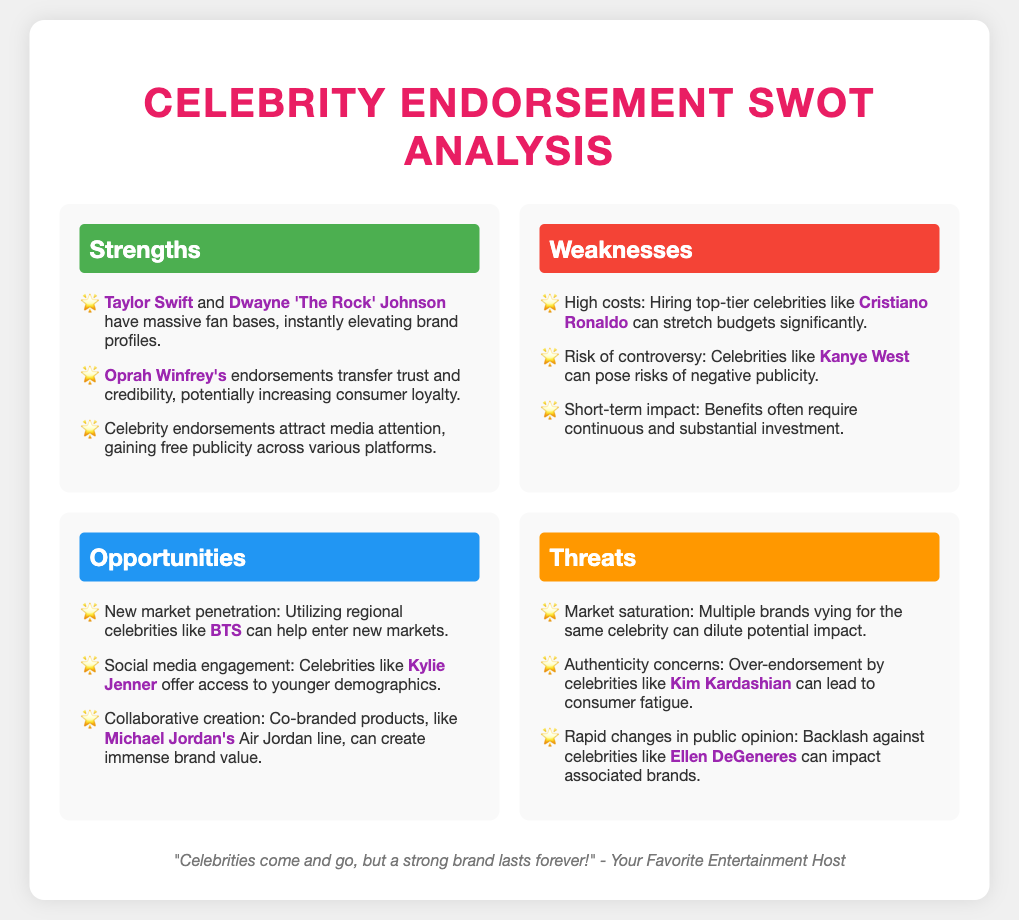What are the strengths listed in the document? The strengths section includes points about celebrities with massive fan bases that enhance brand profiles, endorsements that transfer trust, and media attention attracting free publicity.
Answer: Massive fan bases, trust and credibility, media attention Which celebrity is mentioned as a risk of controversy? The weaknesses section highlights the potential risk of negative publicity associated with certain celebrities.
Answer: Kanye West What type of opportunities does the document highlight for entering new markets? The opportunities section suggests utilizing regional celebrities for market penetration as a strategy.
Answer: Regional celebrities How many celebrities are mentioned in the strengths section? The strengths section lists three celebrities, indicating their influence on brand endorsement strategies.
Answer: Three celebrities What is noted as a threat related to celebrity endorsements? The threats section outlines concerns regarding market saturation and the effects on brand impact.
Answer: Market saturation 